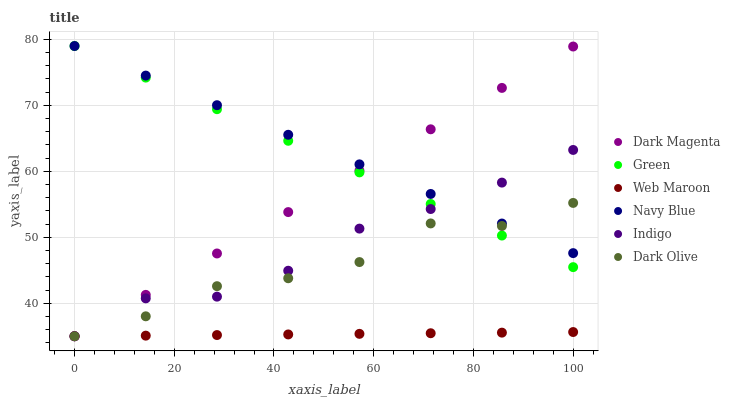Does Web Maroon have the minimum area under the curve?
Answer yes or no. Yes. Does Navy Blue have the maximum area under the curve?
Answer yes or no. Yes. Does Dark Magenta have the minimum area under the curve?
Answer yes or no. No. Does Dark Magenta have the maximum area under the curve?
Answer yes or no. No. Is Dark Magenta the smoothest?
Answer yes or no. Yes. Is Dark Olive the roughest?
Answer yes or no. Yes. Is Navy Blue the smoothest?
Answer yes or no. No. Is Navy Blue the roughest?
Answer yes or no. No. Does Indigo have the lowest value?
Answer yes or no. Yes. Does Navy Blue have the lowest value?
Answer yes or no. No. Does Green have the highest value?
Answer yes or no. Yes. Does Dark Magenta have the highest value?
Answer yes or no. No. Is Web Maroon less than Green?
Answer yes or no. Yes. Is Navy Blue greater than Web Maroon?
Answer yes or no. Yes. Does Dark Magenta intersect Indigo?
Answer yes or no. Yes. Is Dark Magenta less than Indigo?
Answer yes or no. No. Is Dark Magenta greater than Indigo?
Answer yes or no. No. Does Web Maroon intersect Green?
Answer yes or no. No. 